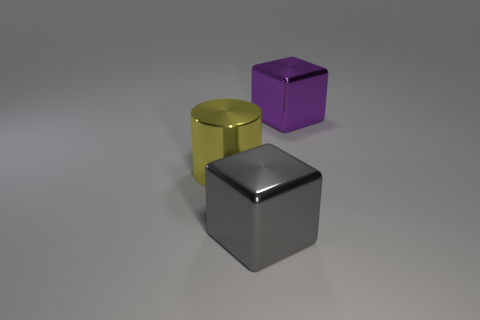What color is the large cube that is made of the same material as the big purple thing? gray 